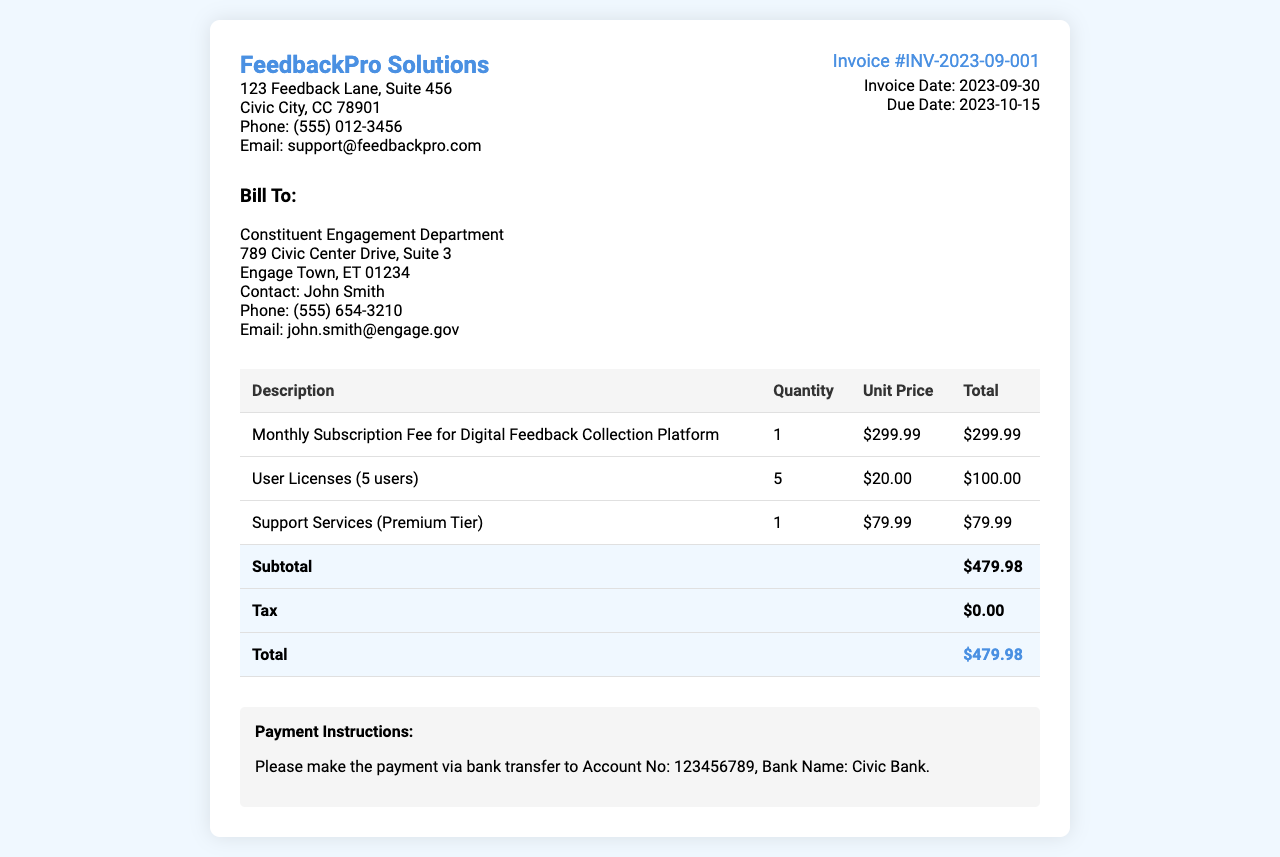What is the invoice number? The invoice number is listed in the document under invoice details as a unique identifier for this transaction.
Answer: INV-2023-09-001 When is the invoice date? The invoice date is specified in the document, indicating when the invoice was generated.
Answer: 2023-09-30 What is the total amount due? The total amount due is the final calculated amount that must be paid, found at the bottom of the invoice.
Answer: $479.98 How many user licenses are included? The document specifies the number of user licenses provided in the breakdown of services.
Answer: 5 What is the unit price for support services? The unit price for support services is detailed in the invoice's itemized list of charges.
Answer: $79.99 What is the subtotal amount before tax? The subtotal represents the total of all charges before tax is applied, shown in the invoice table.
Answer: $479.98 What payment method is suggested? The payment instructions section indicates the preferred method of payment for settling the invoice.
Answer: Bank transfer Who is the contact person for the billing? The document provides a specific name associated with the billing department for any inquiries.
Answer: John Smith What is the due date for the invoice payment? The due date is crucial for understanding when the payment is expected and is clearly listed in the invoice details.
Answer: 2023-10-15 